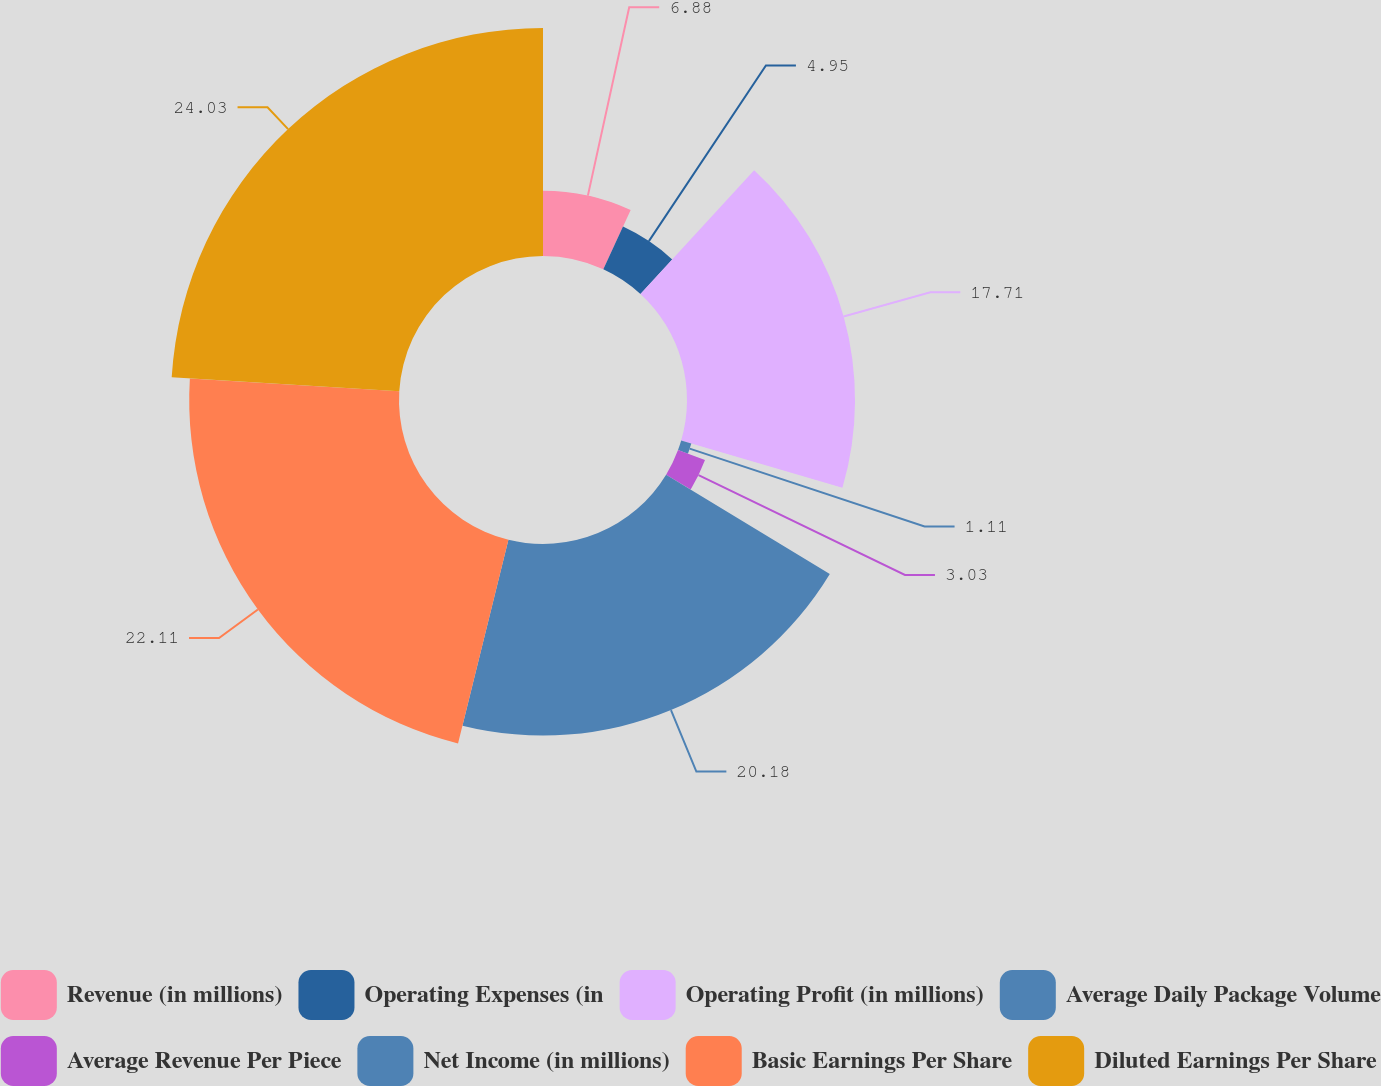Convert chart. <chart><loc_0><loc_0><loc_500><loc_500><pie_chart><fcel>Revenue (in millions)<fcel>Operating Expenses (in<fcel>Operating Profit (in millions)<fcel>Average Daily Package Volume<fcel>Average Revenue Per Piece<fcel>Net Income (in millions)<fcel>Basic Earnings Per Share<fcel>Diluted Earnings Per Share<nl><fcel>6.88%<fcel>4.95%<fcel>17.71%<fcel>1.11%<fcel>3.03%<fcel>20.18%<fcel>22.11%<fcel>24.03%<nl></chart> 